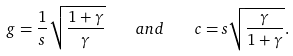<formula> <loc_0><loc_0><loc_500><loc_500>g = \frac { 1 } { s } \sqrt { \frac { 1 + \gamma } { \gamma } } \quad a n d \quad c = s \sqrt { \frac { \gamma } { 1 + \gamma } } .</formula> 